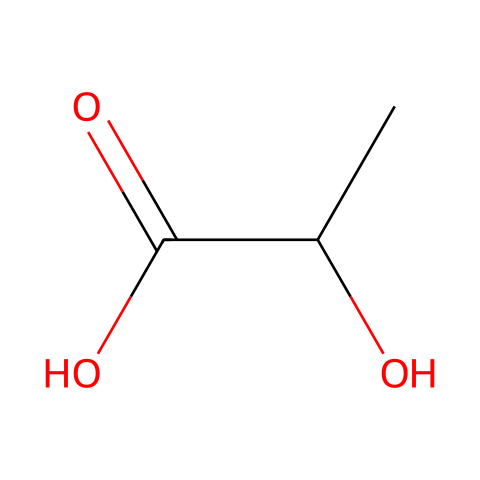What is the name of the chemical represented? The SMILES representation corresponds to a lactic acid molecule, which is known as 2-hydroxypropanoic acid.
Answer: lactic acid How many carbon (C) atoms are present in the chemical? The structure indicates that there are three carbon atoms, as seen in the chain and functional groups of the compound.
Answer: 3 How many functional groups can be identified in the molecule? The chemical features two functional groups: a hydroxyl (-OH) and a carboxylic acid (-COOH) group.
Answer: 2 What is the molecular formula of this chemical? From the SMILES representation, we can derive the molecular formula as C3H6O3, which represents the constituents of the molecule.
Answer: C3H6O3 What type of polymer can this molecule form? This molecule can undergo polymerization to form polylactic acid (PLA), showcasing its capacity to create biodegradable plastics.
Answer: polylactic acid Why is this chemical considered biodegradable? The presence of ester bonds in PLA allows microbial activity to break it down into natural by-products like carbon dioxide and water, making it biodegradable.
Answer: microbial activity 